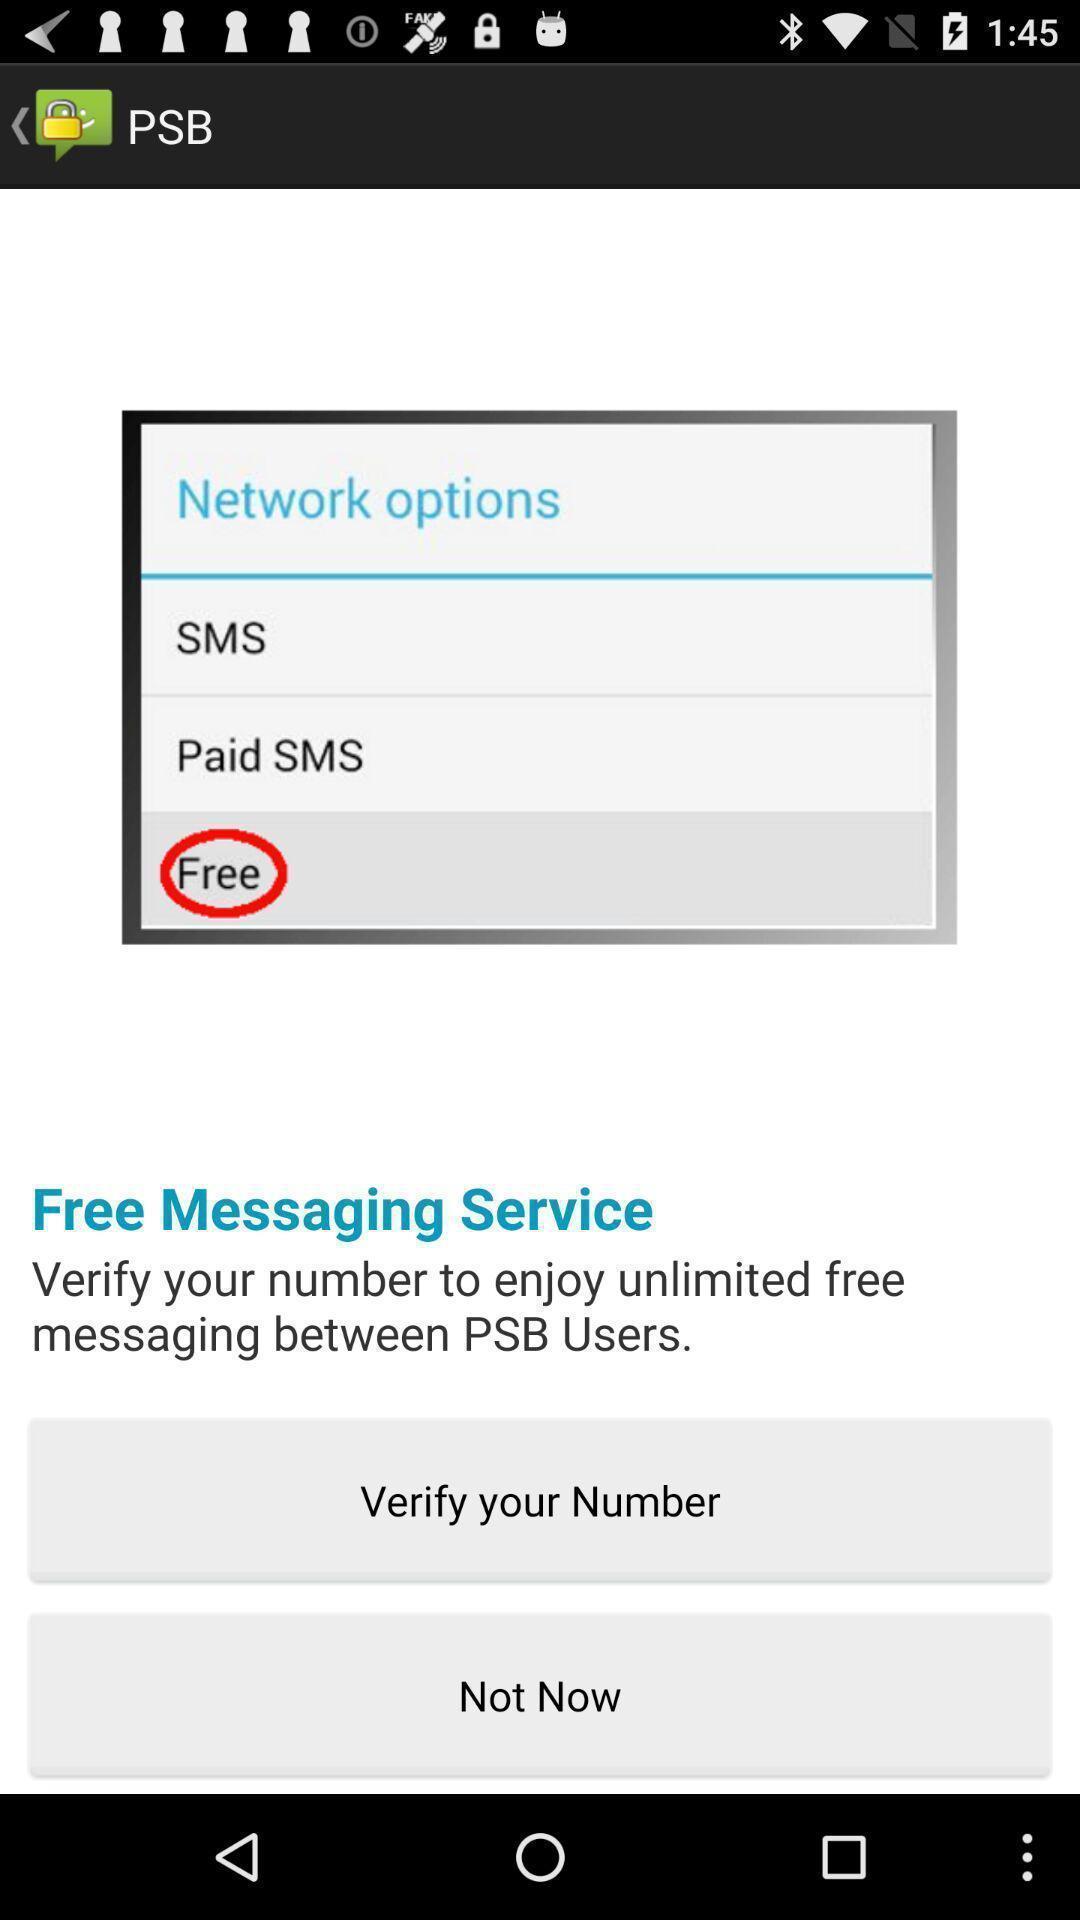Describe the visual elements of this screenshot. Welcome screen displaying option to verify number. 